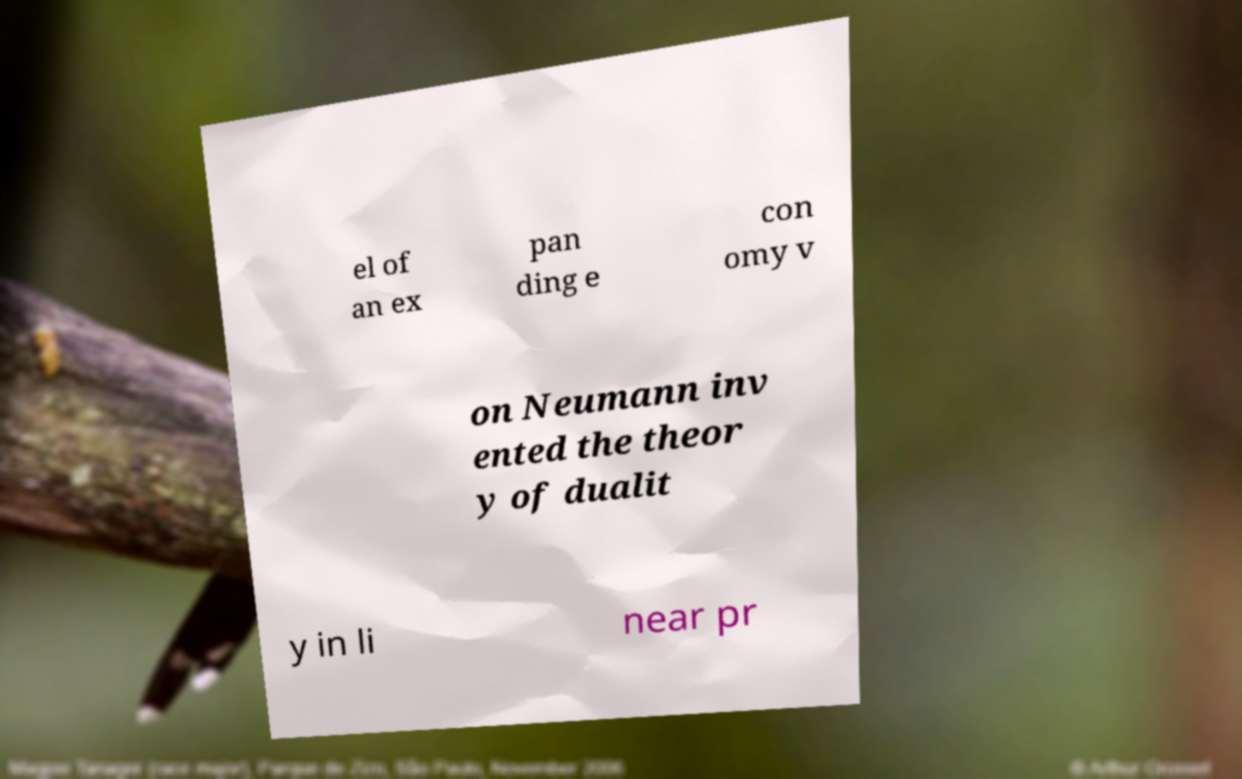Could you assist in decoding the text presented in this image and type it out clearly? el of an ex pan ding e con omy v on Neumann inv ented the theor y of dualit y in li near pr 